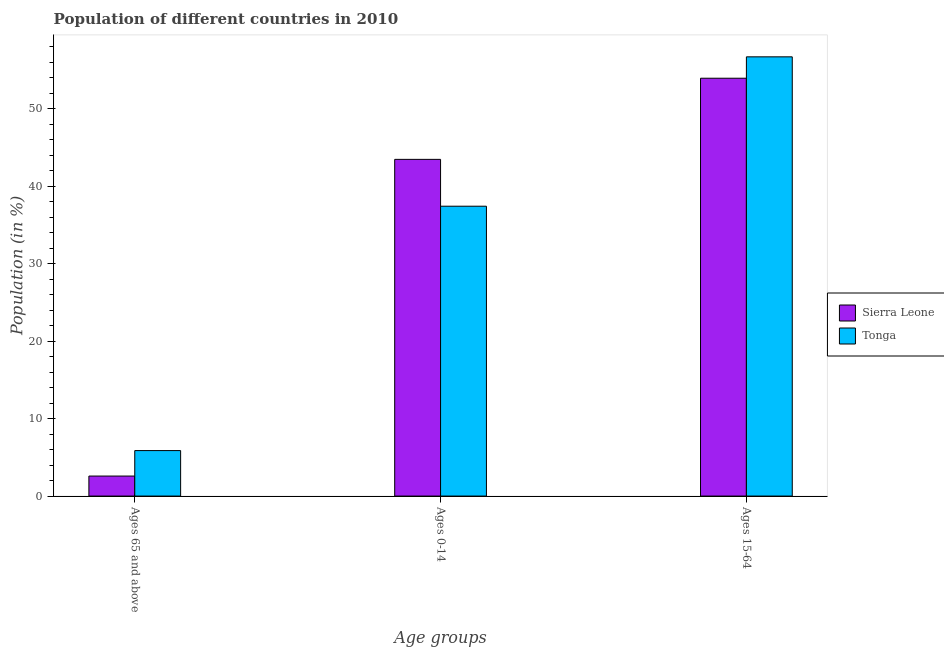How many different coloured bars are there?
Give a very brief answer. 2. How many groups of bars are there?
Your answer should be very brief. 3. Are the number of bars per tick equal to the number of legend labels?
Offer a very short reply. Yes. How many bars are there on the 3rd tick from the right?
Offer a terse response. 2. What is the label of the 1st group of bars from the left?
Your answer should be compact. Ages 65 and above. What is the percentage of population within the age-group 15-64 in Sierra Leone?
Ensure brevity in your answer.  53.95. Across all countries, what is the maximum percentage of population within the age-group 0-14?
Your response must be concise. 43.47. Across all countries, what is the minimum percentage of population within the age-group 15-64?
Provide a short and direct response. 53.95. In which country was the percentage of population within the age-group 15-64 maximum?
Ensure brevity in your answer.  Tonga. In which country was the percentage of population within the age-group 0-14 minimum?
Make the answer very short. Tonga. What is the total percentage of population within the age-group 15-64 in the graph?
Give a very brief answer. 110.65. What is the difference between the percentage of population within the age-group 0-14 in Sierra Leone and that in Tonga?
Your response must be concise. 6.05. What is the difference between the percentage of population within the age-group of 65 and above in Sierra Leone and the percentage of population within the age-group 0-14 in Tonga?
Your answer should be compact. -34.84. What is the average percentage of population within the age-group of 65 and above per country?
Keep it short and to the point. 4.23. What is the difference between the percentage of population within the age-group of 65 and above and percentage of population within the age-group 0-14 in Tonga?
Keep it short and to the point. -31.55. What is the ratio of the percentage of population within the age-group 0-14 in Tonga to that in Sierra Leone?
Your response must be concise. 0.86. Is the percentage of population within the age-group 0-14 in Tonga less than that in Sierra Leone?
Ensure brevity in your answer.  Yes. What is the difference between the highest and the second highest percentage of population within the age-group 15-64?
Your answer should be compact. 2.76. What is the difference between the highest and the lowest percentage of population within the age-group of 65 and above?
Provide a short and direct response. 3.29. What does the 2nd bar from the left in Ages 0-14 represents?
Offer a terse response. Tonga. What does the 1st bar from the right in Ages 65 and above represents?
Keep it short and to the point. Tonga. Is it the case that in every country, the sum of the percentage of population within the age-group of 65 and above and percentage of population within the age-group 0-14 is greater than the percentage of population within the age-group 15-64?
Provide a succinct answer. No. What is the difference between two consecutive major ticks on the Y-axis?
Make the answer very short. 10. Does the graph contain grids?
Keep it short and to the point. No. Where does the legend appear in the graph?
Your answer should be compact. Center right. How many legend labels are there?
Your answer should be very brief. 2. What is the title of the graph?
Ensure brevity in your answer.  Population of different countries in 2010. What is the label or title of the X-axis?
Give a very brief answer. Age groups. What is the label or title of the Y-axis?
Ensure brevity in your answer.  Population (in %). What is the Population (in %) in Sierra Leone in Ages 65 and above?
Make the answer very short. 2.58. What is the Population (in %) of Tonga in Ages 65 and above?
Ensure brevity in your answer.  5.87. What is the Population (in %) of Sierra Leone in Ages 0-14?
Offer a terse response. 43.47. What is the Population (in %) in Tonga in Ages 0-14?
Provide a succinct answer. 37.42. What is the Population (in %) in Sierra Leone in Ages 15-64?
Offer a very short reply. 53.95. What is the Population (in %) of Tonga in Ages 15-64?
Offer a terse response. 56.71. Across all Age groups, what is the maximum Population (in %) in Sierra Leone?
Provide a succinct answer. 53.95. Across all Age groups, what is the maximum Population (in %) of Tonga?
Your response must be concise. 56.71. Across all Age groups, what is the minimum Population (in %) in Sierra Leone?
Provide a succinct answer. 2.58. Across all Age groups, what is the minimum Population (in %) in Tonga?
Keep it short and to the point. 5.87. What is the difference between the Population (in %) of Sierra Leone in Ages 65 and above and that in Ages 0-14?
Offer a terse response. -40.89. What is the difference between the Population (in %) in Tonga in Ages 65 and above and that in Ages 0-14?
Your response must be concise. -31.55. What is the difference between the Population (in %) of Sierra Leone in Ages 65 and above and that in Ages 15-64?
Offer a terse response. -51.36. What is the difference between the Population (in %) in Tonga in Ages 65 and above and that in Ages 15-64?
Offer a very short reply. -50.83. What is the difference between the Population (in %) of Sierra Leone in Ages 0-14 and that in Ages 15-64?
Provide a short and direct response. -10.48. What is the difference between the Population (in %) in Tonga in Ages 0-14 and that in Ages 15-64?
Give a very brief answer. -19.29. What is the difference between the Population (in %) of Sierra Leone in Ages 65 and above and the Population (in %) of Tonga in Ages 0-14?
Provide a short and direct response. -34.84. What is the difference between the Population (in %) of Sierra Leone in Ages 65 and above and the Population (in %) of Tonga in Ages 15-64?
Offer a very short reply. -54.12. What is the difference between the Population (in %) of Sierra Leone in Ages 0-14 and the Population (in %) of Tonga in Ages 15-64?
Your answer should be very brief. -13.24. What is the average Population (in %) of Sierra Leone per Age groups?
Give a very brief answer. 33.33. What is the average Population (in %) of Tonga per Age groups?
Keep it short and to the point. 33.33. What is the difference between the Population (in %) of Sierra Leone and Population (in %) of Tonga in Ages 65 and above?
Your response must be concise. -3.29. What is the difference between the Population (in %) in Sierra Leone and Population (in %) in Tonga in Ages 0-14?
Make the answer very short. 6.05. What is the difference between the Population (in %) in Sierra Leone and Population (in %) in Tonga in Ages 15-64?
Offer a terse response. -2.76. What is the ratio of the Population (in %) of Sierra Leone in Ages 65 and above to that in Ages 0-14?
Keep it short and to the point. 0.06. What is the ratio of the Population (in %) of Tonga in Ages 65 and above to that in Ages 0-14?
Your answer should be very brief. 0.16. What is the ratio of the Population (in %) of Sierra Leone in Ages 65 and above to that in Ages 15-64?
Ensure brevity in your answer.  0.05. What is the ratio of the Population (in %) in Tonga in Ages 65 and above to that in Ages 15-64?
Your response must be concise. 0.1. What is the ratio of the Population (in %) of Sierra Leone in Ages 0-14 to that in Ages 15-64?
Offer a very short reply. 0.81. What is the ratio of the Population (in %) in Tonga in Ages 0-14 to that in Ages 15-64?
Give a very brief answer. 0.66. What is the difference between the highest and the second highest Population (in %) in Sierra Leone?
Ensure brevity in your answer.  10.48. What is the difference between the highest and the second highest Population (in %) of Tonga?
Make the answer very short. 19.29. What is the difference between the highest and the lowest Population (in %) in Sierra Leone?
Offer a very short reply. 51.36. What is the difference between the highest and the lowest Population (in %) in Tonga?
Provide a short and direct response. 50.83. 